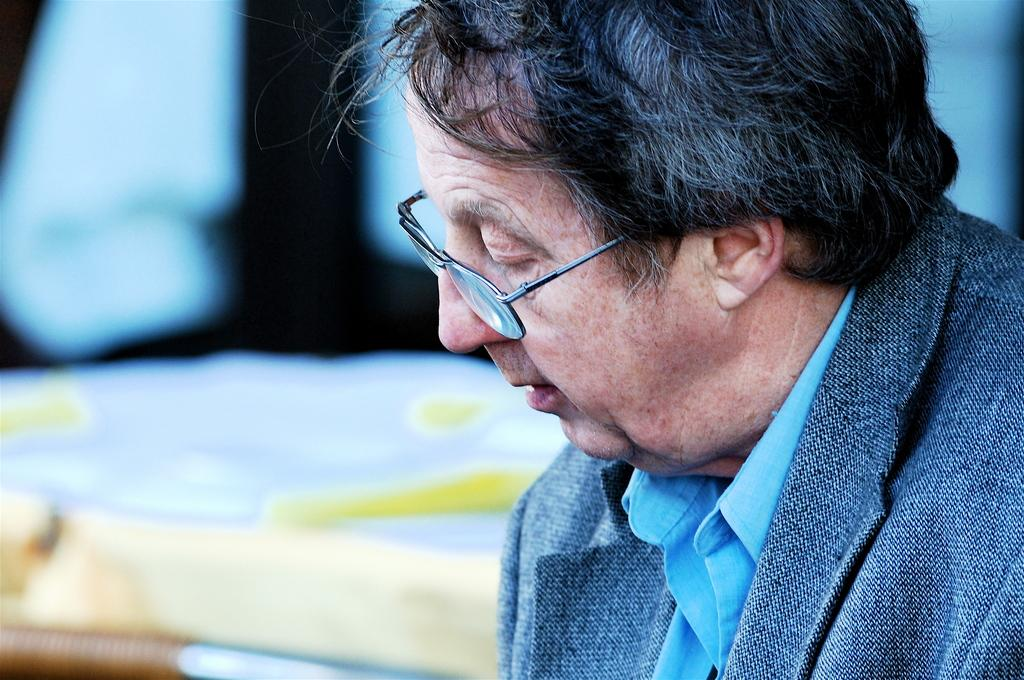What can be seen on the right side of the image? There is a person on the right side of the image. What is the person wearing in the image? The person is wearing spectacles in the image. Can you describe the background of the image? The background of the image is blurry. What type of engine can be seen in the image? There is no engine present in the image. How does the coastline appear in the image? There is no coastline present in the image. 